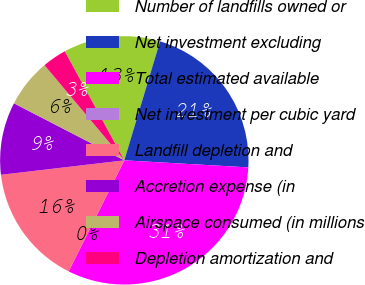<chart> <loc_0><loc_0><loc_500><loc_500><pie_chart><fcel>Number of landfills owned or<fcel>Net investment excluding<fcel>Total estimated available<fcel>Net investment per cubic yard<fcel>Landfill depletion and<fcel>Accretion expense (in<fcel>Airspace consumed (in millions<fcel>Depletion amortization and<nl><fcel>12.6%<fcel>21.26%<fcel>31.49%<fcel>0.0%<fcel>15.75%<fcel>9.45%<fcel>6.3%<fcel>3.15%<nl></chart> 